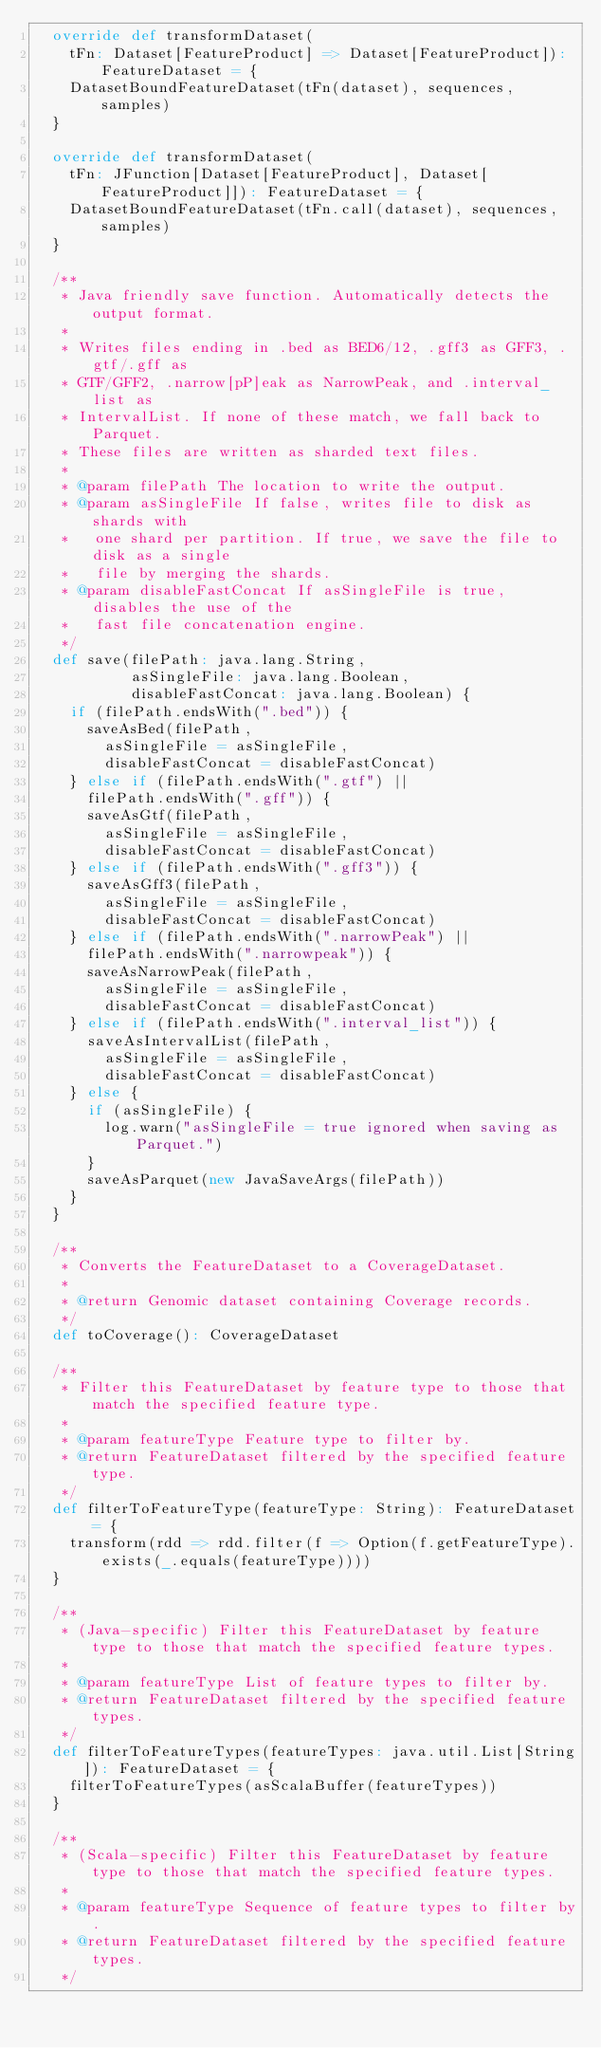<code> <loc_0><loc_0><loc_500><loc_500><_Scala_>  override def transformDataset(
    tFn: Dataset[FeatureProduct] => Dataset[FeatureProduct]): FeatureDataset = {
    DatasetBoundFeatureDataset(tFn(dataset), sequences, samples)
  }

  override def transformDataset(
    tFn: JFunction[Dataset[FeatureProduct], Dataset[FeatureProduct]]): FeatureDataset = {
    DatasetBoundFeatureDataset(tFn.call(dataset), sequences, samples)
  }

  /**
   * Java friendly save function. Automatically detects the output format.
   *
   * Writes files ending in .bed as BED6/12, .gff3 as GFF3, .gtf/.gff as
   * GTF/GFF2, .narrow[pP]eak as NarrowPeak, and .interval_list as
   * IntervalList. If none of these match, we fall back to Parquet.
   * These files are written as sharded text files.
   *
   * @param filePath The location to write the output.
   * @param asSingleFile If false, writes file to disk as shards with
   *   one shard per partition. If true, we save the file to disk as a single
   *   file by merging the shards.
   * @param disableFastConcat If asSingleFile is true, disables the use of the
   *   fast file concatenation engine.
   */
  def save(filePath: java.lang.String,
           asSingleFile: java.lang.Boolean,
           disableFastConcat: java.lang.Boolean) {
    if (filePath.endsWith(".bed")) {
      saveAsBed(filePath,
        asSingleFile = asSingleFile,
        disableFastConcat = disableFastConcat)
    } else if (filePath.endsWith(".gtf") ||
      filePath.endsWith(".gff")) {
      saveAsGtf(filePath,
        asSingleFile = asSingleFile,
        disableFastConcat = disableFastConcat)
    } else if (filePath.endsWith(".gff3")) {
      saveAsGff3(filePath,
        asSingleFile = asSingleFile,
        disableFastConcat = disableFastConcat)
    } else if (filePath.endsWith(".narrowPeak") ||
      filePath.endsWith(".narrowpeak")) {
      saveAsNarrowPeak(filePath,
        asSingleFile = asSingleFile,
        disableFastConcat = disableFastConcat)
    } else if (filePath.endsWith(".interval_list")) {
      saveAsIntervalList(filePath,
        asSingleFile = asSingleFile,
        disableFastConcat = disableFastConcat)
    } else {
      if (asSingleFile) {
        log.warn("asSingleFile = true ignored when saving as Parquet.")
      }
      saveAsParquet(new JavaSaveArgs(filePath))
    }
  }

  /**
   * Converts the FeatureDataset to a CoverageDataset.
   *
   * @return Genomic dataset containing Coverage records.
   */
  def toCoverage(): CoverageDataset

  /**
   * Filter this FeatureDataset by feature type to those that match the specified feature type.
   *
   * @param featureType Feature type to filter by.
   * @return FeatureDataset filtered by the specified feature type.
   */
  def filterToFeatureType(featureType: String): FeatureDataset = {
    transform(rdd => rdd.filter(f => Option(f.getFeatureType).exists(_.equals(featureType))))
  }

  /**
   * (Java-specific) Filter this FeatureDataset by feature type to those that match the specified feature types.
   *
   * @param featureType List of feature types to filter by.
   * @return FeatureDataset filtered by the specified feature types.
   */
  def filterToFeatureTypes(featureTypes: java.util.List[String]): FeatureDataset = {
    filterToFeatureTypes(asScalaBuffer(featureTypes))
  }

  /**
   * (Scala-specific) Filter this FeatureDataset by feature type to those that match the specified feature types.
   *
   * @param featureType Sequence of feature types to filter by.
   * @return FeatureDataset filtered by the specified feature types.
   */</code> 